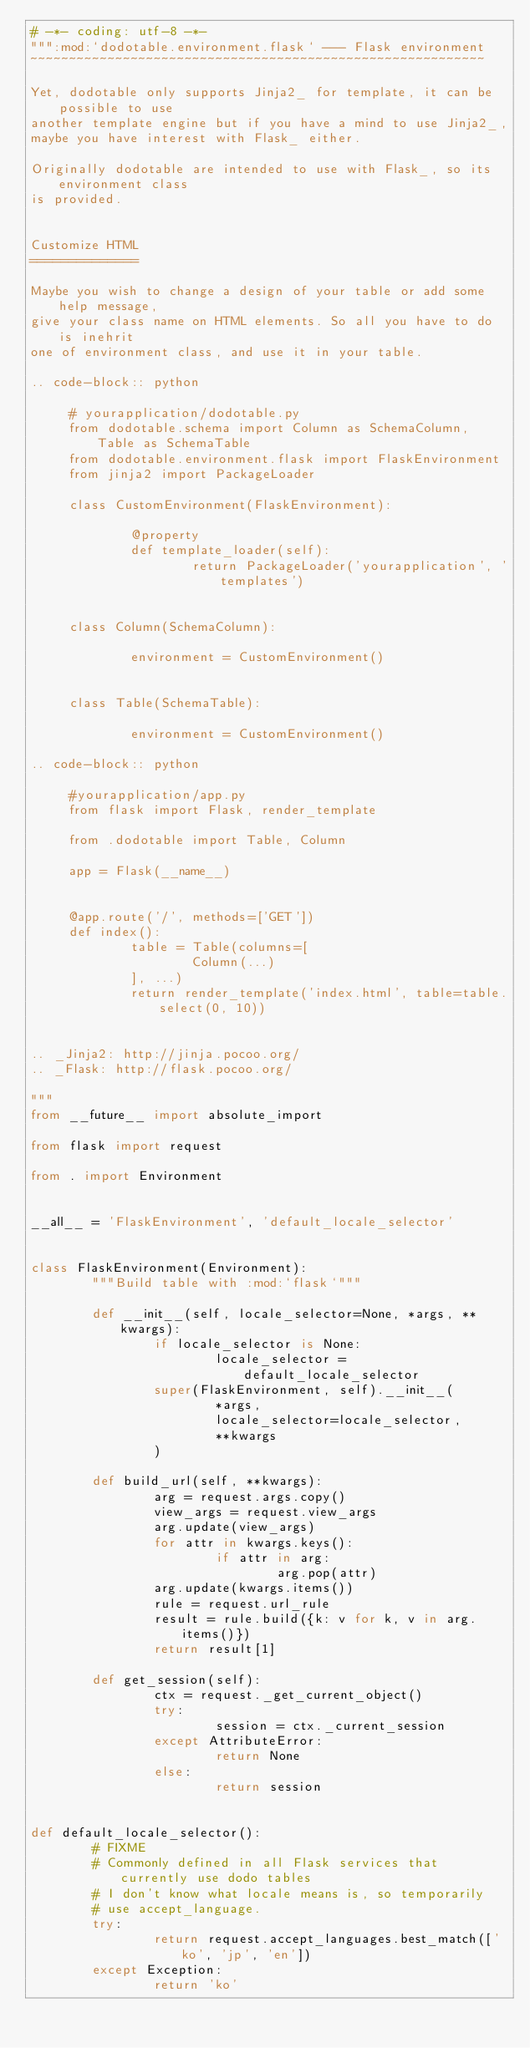<code> <loc_0><loc_0><loc_500><loc_500><_Python_># -*- coding: utf-8 -*-
""":mod:`dodotable.environment.flask` --- Flask environment
~~~~~~~~~~~~~~~~~~~~~~~~~~~~~~~~~~~~~~~~~~~~~~~~~~~~~~~~~~~

Yet, dodotable only supports Jinja2_ for template, it can be possible to use
another template engine but if you have a mind to use Jinja2_,
maybe you have interest with Flask_ either.

Originally dodotable are intended to use with Flask_, so its environment class
is provided.


Customize HTML
==============

Maybe you wish to change a design of your table or add some help message,
give your class name on HTML elements. So all you have to do is inehrit
one of environment class, and use it in your table.

.. code-block:: python

	 # yourapplication/dodotable.py
	 from dodotable.schema import Column as SchemaColumn, Table as SchemaTable
	 from dodotable.environment.flask import FlaskEnvironment
	 from jinja2 import PackageLoader

	 class CustomEnvironment(FlaskEnvironment):

			 @property
			 def template_loader(self):
					 return PackageLoader('yourapplication', 'templates')


	 class Column(SchemaColumn):

			 environment = CustomEnvironment()


	 class Table(SchemaTable):

			 environment = CustomEnvironment()

.. code-block:: python

	 #yourapplication/app.py
	 from flask import Flask, render_template

	 from .dodotable import Table, Column

	 app = Flask(__name__)


	 @app.route('/', methods=['GET'])
	 def index():
			 table = Table(columns=[
					 Column(...)
			 ], ...)
			 return render_template('index.html', table=table.select(0, 10))


.. _Jinja2: http://jinja.pocoo.org/
.. _Flask: http://flask.pocoo.org/

"""
from __future__ import absolute_import

from flask import request

from . import Environment


__all__ = 'FlaskEnvironment', 'default_locale_selector'


class FlaskEnvironment(Environment):
		"""Build table with :mod:`flask`"""

		def __init__(self, locale_selector=None, *args, **kwargs):
				if locale_selector is None:
						locale_selector = default_locale_selector
				super(FlaskEnvironment, self).__init__(
						*args,
						locale_selector=locale_selector,
						**kwargs
				)

		def build_url(self, **kwargs):
				arg = request.args.copy()
				view_args = request.view_args
				arg.update(view_args)
				for attr in kwargs.keys():
						if attr in arg:
								arg.pop(attr)
				arg.update(kwargs.items())
				rule = request.url_rule
				result = rule.build({k: v for k, v in arg.items()})
				return result[1]

		def get_session(self):
				ctx = request._get_current_object()
				try:
						session = ctx._current_session
				except AttributeError:
						return None
				else:
						return session


def default_locale_selector():
		# FIXME
		# Commonly defined in all Flask services that currently use dodo tables
		# I don't know what locale means is, so temporarily
		# use accept_language.
		try:
				return request.accept_languages.best_match(['ko', 'jp', 'en'])
		except Exception:
				return 'ko'
</code> 